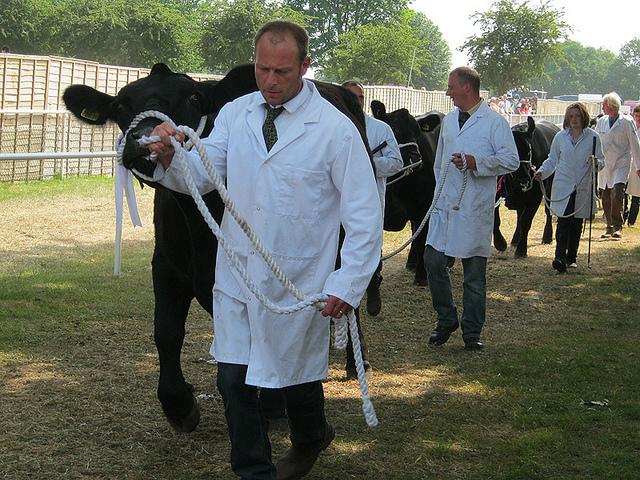What color pants is the woman wearing?
Short answer required. Black. Are these people dressed like farmers?
Give a very brief answer. No. What are these animals?
Give a very brief answer. Cows. 